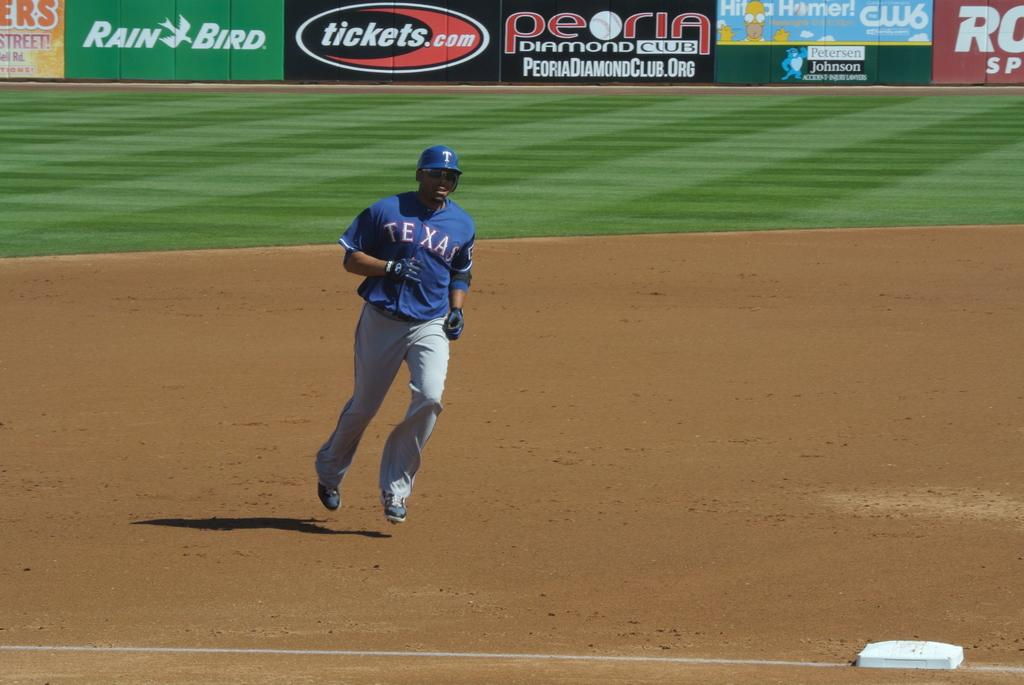<image>
Describe the image concisely. Baseball player from team Texas is running to the third base. 